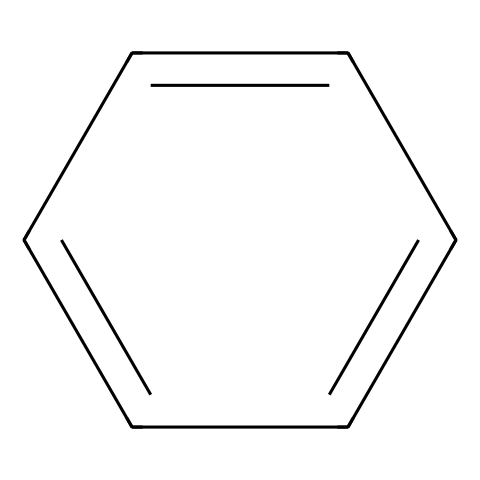What is the name of this chemical? The SMILES representation c1ccccc1 corresponds to benzene, which is a well-known aromatic hydrocarbon.
Answer: benzene How many carbon atoms are in this molecule? The structure indicates there are six carbon atoms present in the benzene ring, as each 'c' in the SMILES represents a carbon atom.
Answer: six What type of hydrocarbon is benzene classified as? Benzene, with its ring structure and alternating double bonds, is classified as an aromatic hydrocarbon, which is characterized by delocalized pi electrons.
Answer: aromatic What is the total number of hydrogen atoms in benzene? Each carbon in benzene is bonded to one hydrogen atom in addition to forming bonds with two neighboring carbons, giving benzene a total of six hydrogen atoms, calculated as 6 (carbon) + 6 (hydrogen) = 6.
Answer: six Is benzene a polar or nonpolar solvent? Benzene is a nonpolar solvent due to its symmetrical structure and lack of significant electronegative differences among its constituent atoms, making it hydrophobic and ideal for dissolving nonpolar substances.
Answer: nonpolar What makes benzene useful in early phonograph record production? Benzene was historically used in the production of early phonograph records due to its excellent solvent characteristics for the plastic materials used, and its ability to dissolve various substances, ensuring a smooth and workable compound for record formation.
Answer: solvent characteristics 